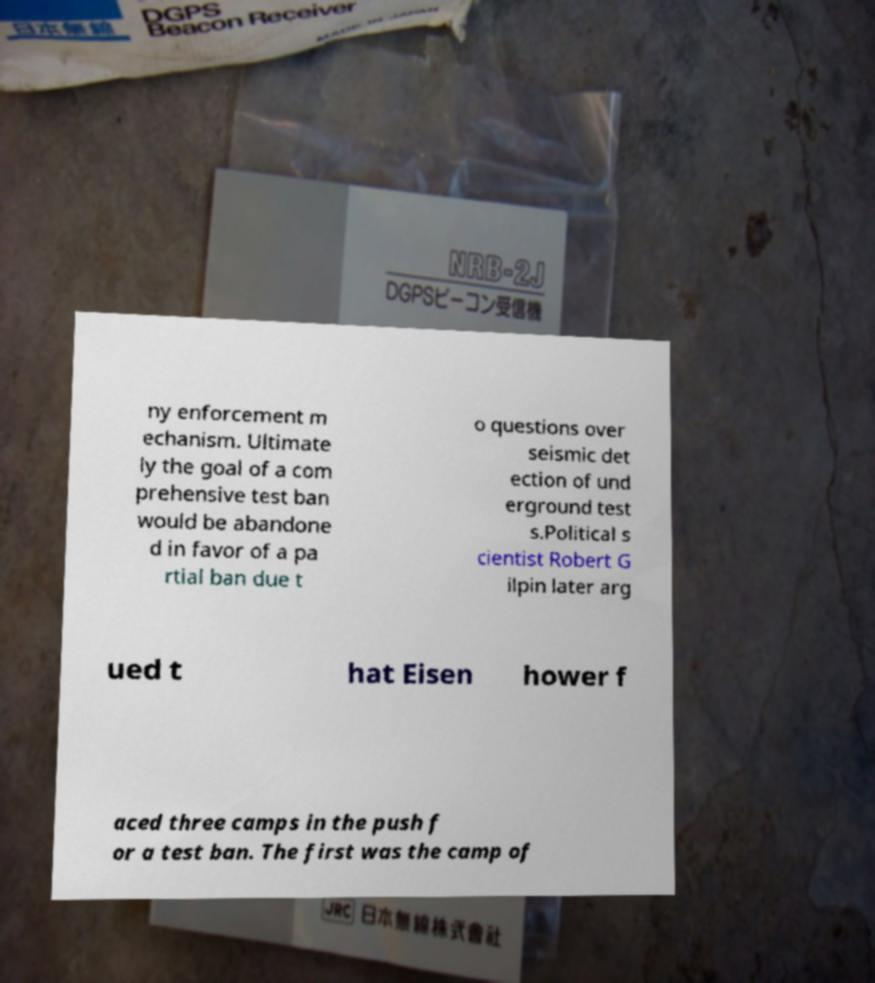Could you extract and type out the text from this image? ny enforcement m echanism. Ultimate ly the goal of a com prehensive test ban would be abandone d in favor of a pa rtial ban due t o questions over seismic det ection of und erground test s.Political s cientist Robert G ilpin later arg ued t hat Eisen hower f aced three camps in the push f or a test ban. The first was the camp of 